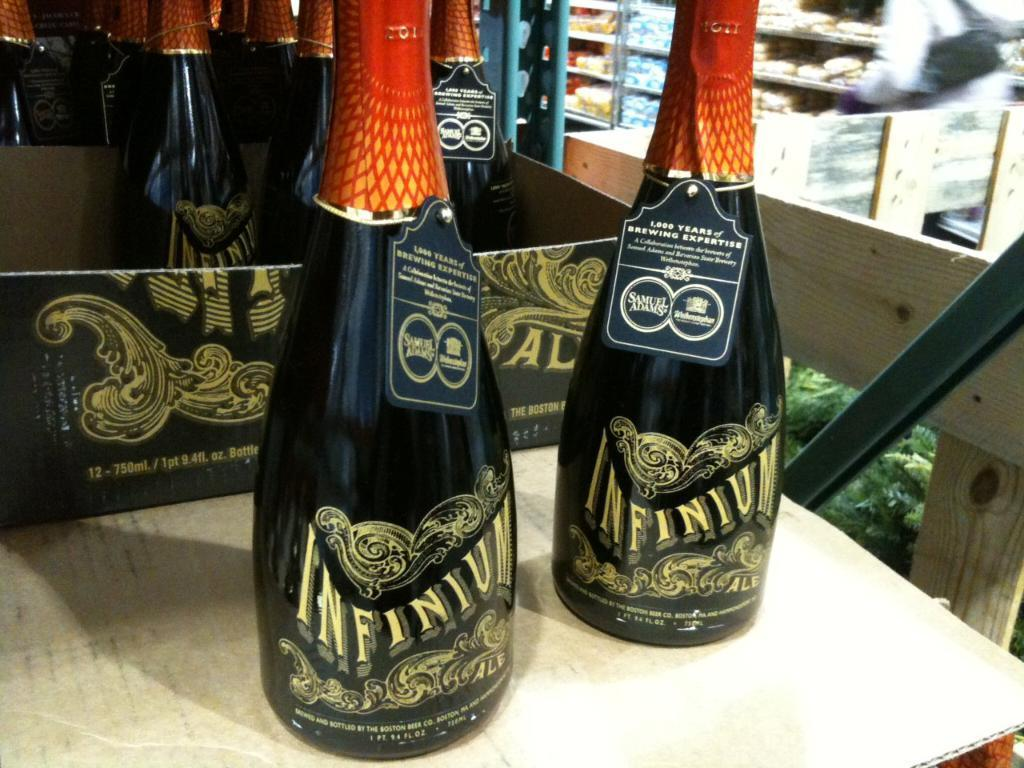<image>
Create a compact narrative representing the image presented. Two bottles of Infinium sit in front of a carrier for the bottles. 